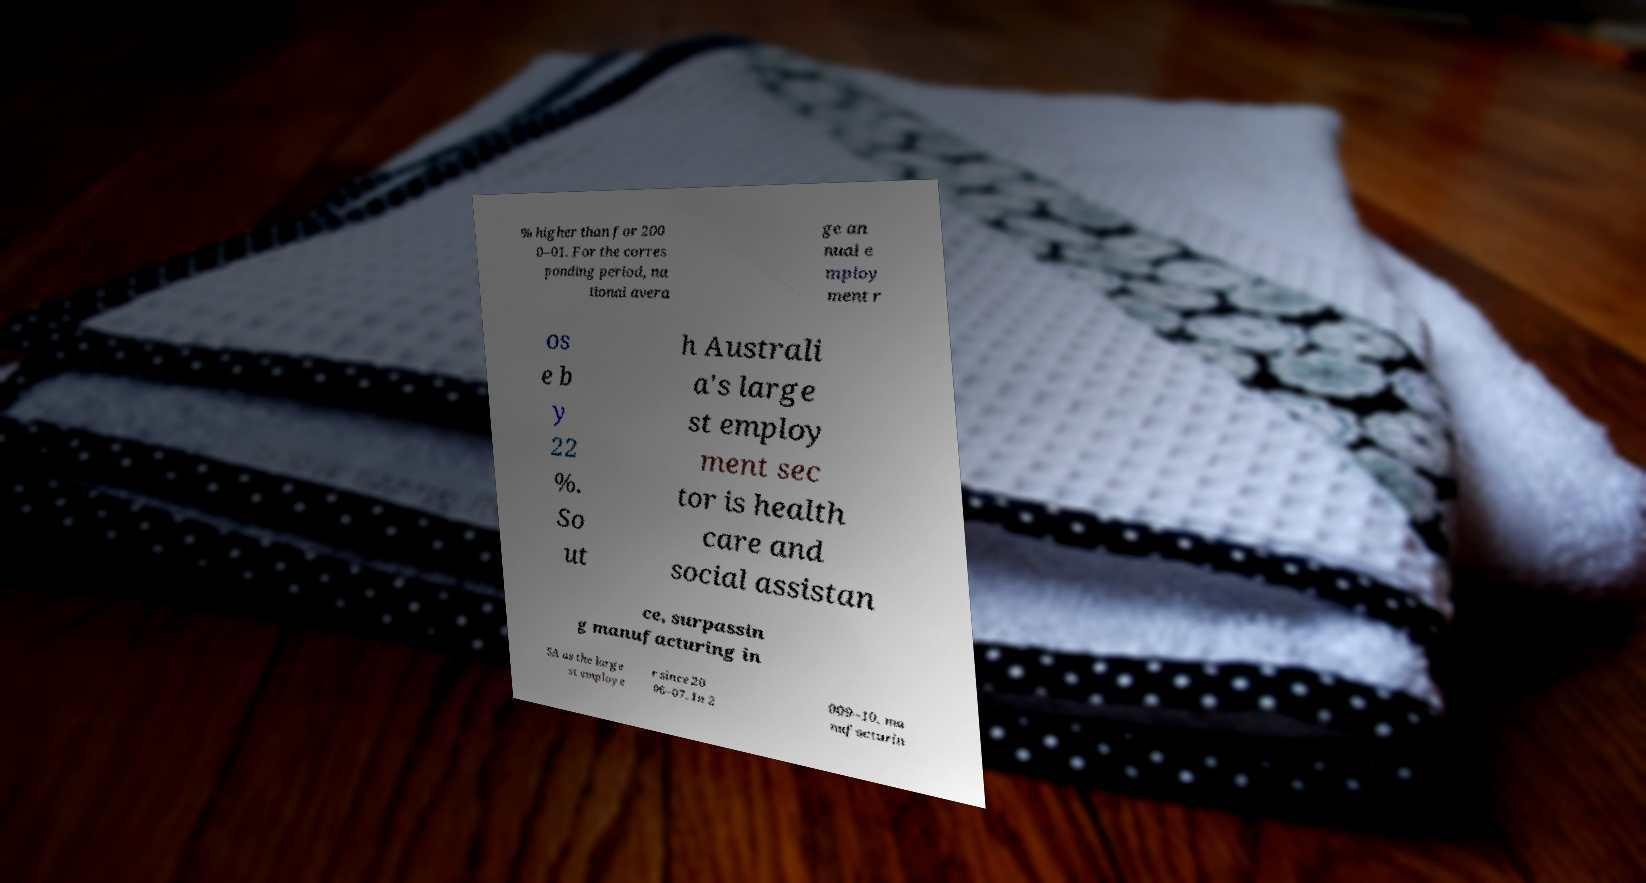For documentation purposes, I need the text within this image transcribed. Could you provide that? % higher than for 200 0–01. For the corres ponding period, na tional avera ge an nual e mploy ment r os e b y 22 %. So ut h Australi a's large st employ ment sec tor is health care and social assistan ce, surpassin g manufacturing in SA as the large st employe r since 20 06–07. In 2 009–10, ma nufacturin 